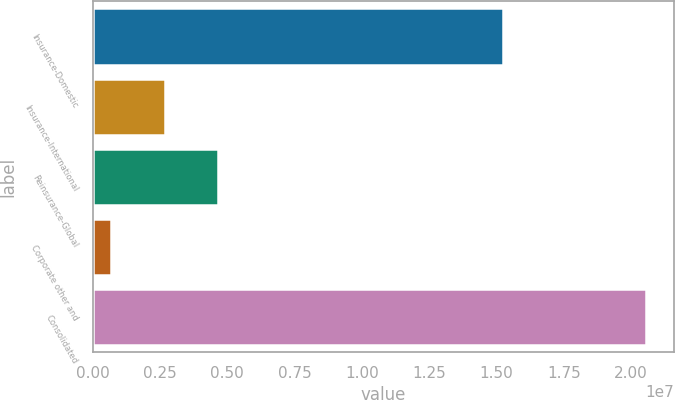Convert chart. <chart><loc_0><loc_0><loc_500><loc_500><bar_chart><fcel>Insurance-Domestic<fcel>Insurance-International<fcel>Reinsurance-Global<fcel>Corporate other and<fcel>Consolidated<nl><fcel>1.52478e+07<fcel>2.67122e+06<fcel>4.65795e+06<fcel>684486<fcel>2.05518e+07<nl></chart> 